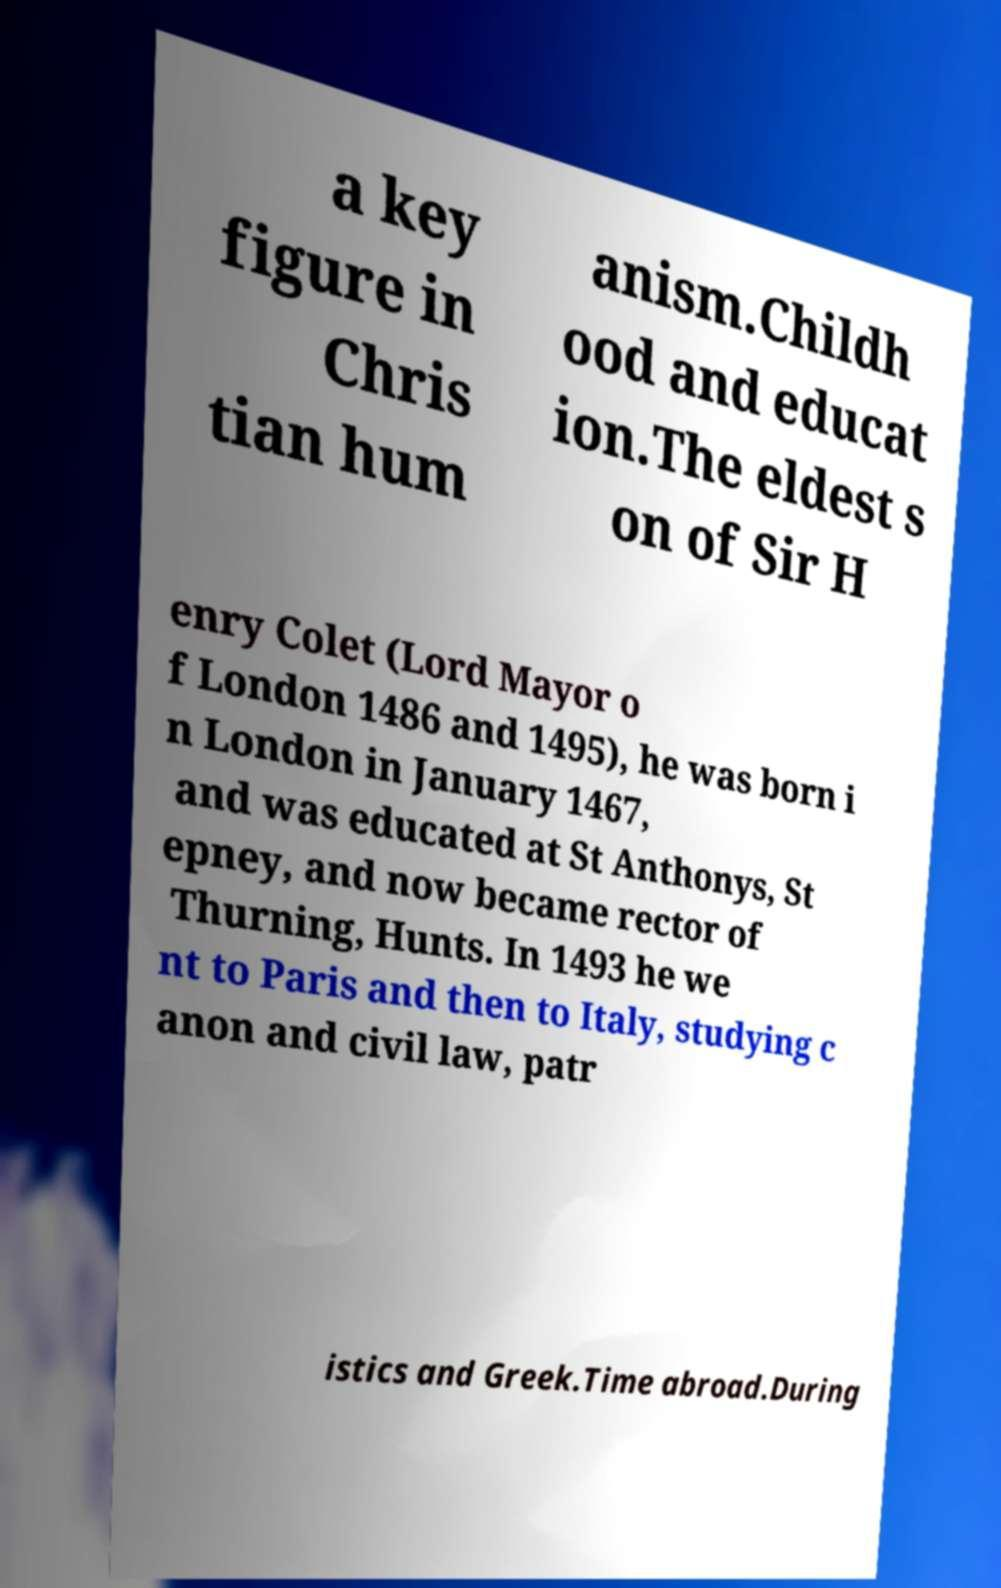There's text embedded in this image that I need extracted. Can you transcribe it verbatim? a key figure in Chris tian hum anism.Childh ood and educat ion.The eldest s on of Sir H enry Colet (Lord Mayor o f London 1486 and 1495), he was born i n London in January 1467, and was educated at St Anthonys, St epney, and now became rector of Thurning, Hunts. In 1493 he we nt to Paris and then to Italy, studying c anon and civil law, patr istics and Greek.Time abroad.During 